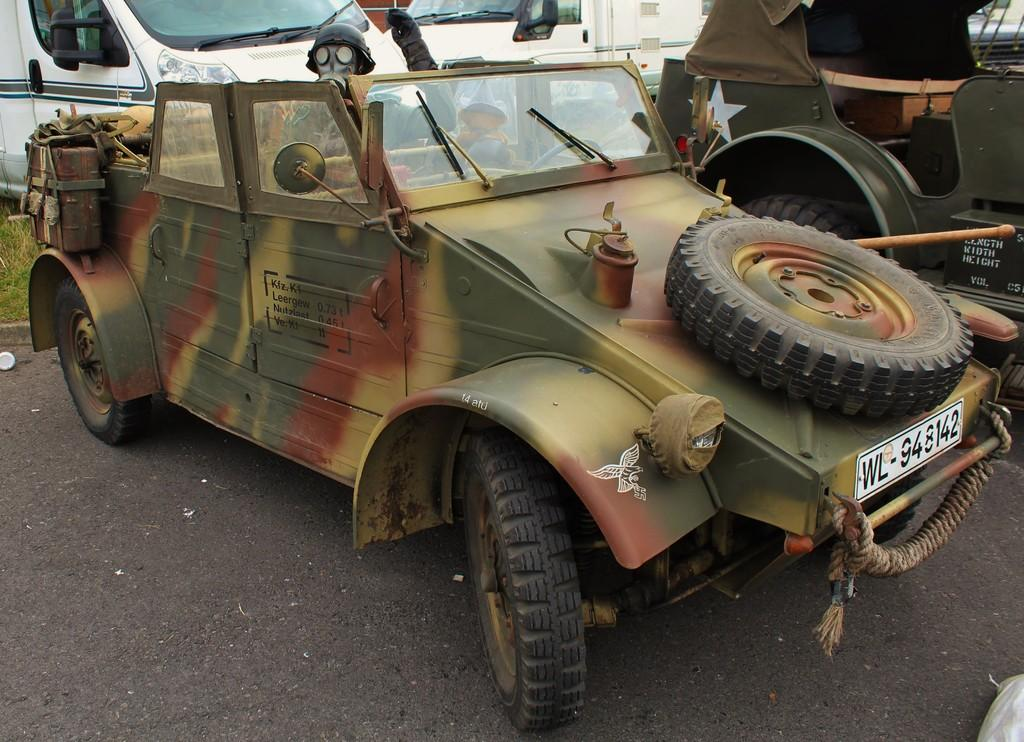What can be seen on the road in the image? There are vehicles parked on the road. What color are the vehicles in the background? The vehicles in the background are white. What type of surface is visible on the ground? There is grass on the ground. How many babies are sitting on the grass in the image? There are no babies present in the image; it only shows vehicles parked on the road and grass on the ground. 